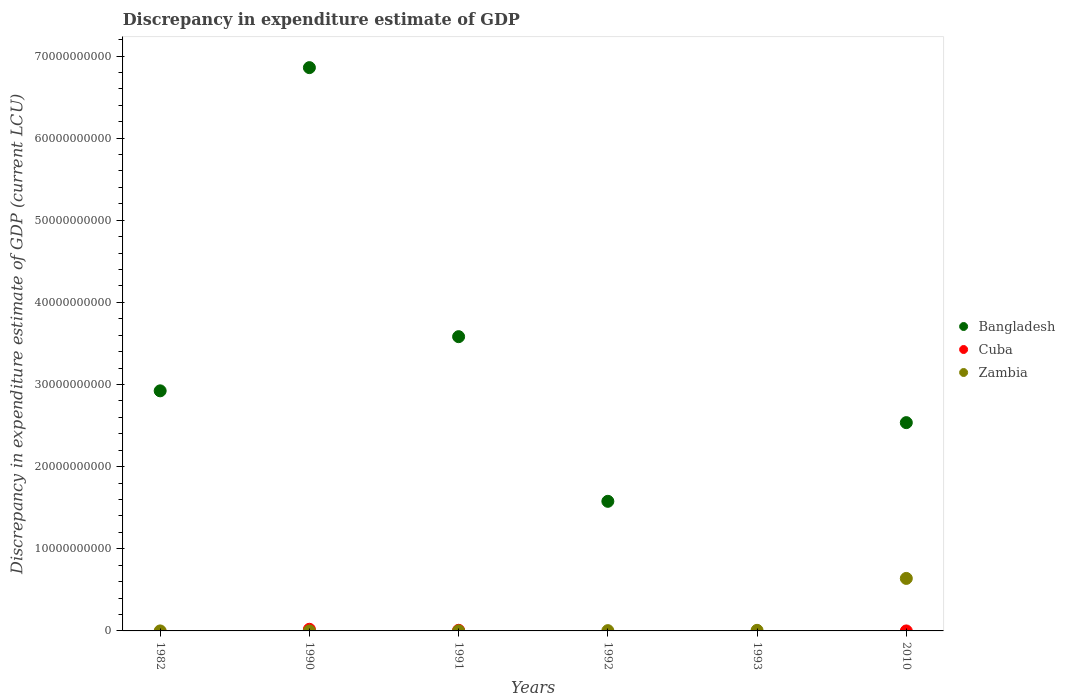What is the discrepancy in expenditure estimate of GDP in Bangladesh in 2010?
Provide a succinct answer. 2.54e+1. Across all years, what is the maximum discrepancy in expenditure estimate of GDP in Cuba?
Offer a terse response. 2.01e+08. Across all years, what is the minimum discrepancy in expenditure estimate of GDP in Cuba?
Provide a short and direct response. 0. In which year was the discrepancy in expenditure estimate of GDP in Bangladesh maximum?
Provide a short and direct response. 1990. What is the total discrepancy in expenditure estimate of GDP in Cuba in the graph?
Your answer should be very brief. 2.78e+08. What is the difference between the discrepancy in expenditure estimate of GDP in Bangladesh in 1992 and that in 2010?
Offer a very short reply. -9.58e+09. What is the difference between the discrepancy in expenditure estimate of GDP in Bangladesh in 1992 and the discrepancy in expenditure estimate of GDP in Cuba in 1990?
Offer a very short reply. 1.56e+1. What is the average discrepancy in expenditure estimate of GDP in Bangladesh per year?
Keep it short and to the point. 2.91e+1. In the year 1991, what is the difference between the discrepancy in expenditure estimate of GDP in Zambia and discrepancy in expenditure estimate of GDP in Cuba?
Make the answer very short. -6.36e+07. What is the ratio of the discrepancy in expenditure estimate of GDP in Bangladesh in 1990 to that in 1991?
Give a very brief answer. 1.91. What is the difference between the highest and the second highest discrepancy in expenditure estimate of GDP in Bangladesh?
Offer a very short reply. 3.28e+1. What is the difference between the highest and the lowest discrepancy in expenditure estimate of GDP in Zambia?
Provide a succinct answer. 6.39e+09. Is the sum of the discrepancy in expenditure estimate of GDP in Bangladesh in 1982 and 2010 greater than the maximum discrepancy in expenditure estimate of GDP in Cuba across all years?
Provide a succinct answer. Yes. Is it the case that in every year, the sum of the discrepancy in expenditure estimate of GDP in Zambia and discrepancy in expenditure estimate of GDP in Cuba  is greater than the discrepancy in expenditure estimate of GDP in Bangladesh?
Ensure brevity in your answer.  No. Does the discrepancy in expenditure estimate of GDP in Zambia monotonically increase over the years?
Provide a short and direct response. Yes. Is the discrepancy in expenditure estimate of GDP in Zambia strictly less than the discrepancy in expenditure estimate of GDP in Cuba over the years?
Give a very brief answer. No. How many dotlines are there?
Keep it short and to the point. 3. What is the difference between two consecutive major ticks on the Y-axis?
Offer a terse response. 1.00e+1. Are the values on the major ticks of Y-axis written in scientific E-notation?
Make the answer very short. No. Does the graph contain any zero values?
Ensure brevity in your answer.  Yes. Does the graph contain grids?
Ensure brevity in your answer.  No. How many legend labels are there?
Your answer should be very brief. 3. How are the legend labels stacked?
Your answer should be very brief. Vertical. What is the title of the graph?
Your response must be concise. Discrepancy in expenditure estimate of GDP. Does "Malawi" appear as one of the legend labels in the graph?
Provide a short and direct response. No. What is the label or title of the Y-axis?
Offer a very short reply. Discrepancy in expenditure estimate of GDP (current LCU). What is the Discrepancy in expenditure estimate of GDP (current LCU) in Bangladesh in 1982?
Provide a succinct answer. 2.92e+1. What is the Discrepancy in expenditure estimate of GDP (current LCU) of Zambia in 1982?
Offer a terse response. 800. What is the Discrepancy in expenditure estimate of GDP (current LCU) in Bangladesh in 1990?
Provide a short and direct response. 6.86e+1. What is the Discrepancy in expenditure estimate of GDP (current LCU) of Cuba in 1990?
Offer a very short reply. 2.01e+08. What is the Discrepancy in expenditure estimate of GDP (current LCU) in Zambia in 1990?
Ensure brevity in your answer.  1.37e+06. What is the Discrepancy in expenditure estimate of GDP (current LCU) in Bangladesh in 1991?
Make the answer very short. 3.58e+1. What is the Discrepancy in expenditure estimate of GDP (current LCU) of Cuba in 1991?
Provide a short and direct response. 7.71e+07. What is the Discrepancy in expenditure estimate of GDP (current LCU) in Zambia in 1991?
Keep it short and to the point. 1.34e+07. What is the Discrepancy in expenditure estimate of GDP (current LCU) of Bangladesh in 1992?
Make the answer very short. 1.58e+1. What is the Discrepancy in expenditure estimate of GDP (current LCU) in Zambia in 1992?
Offer a terse response. 3.46e+07. What is the Discrepancy in expenditure estimate of GDP (current LCU) in Cuba in 1993?
Make the answer very short. 0. What is the Discrepancy in expenditure estimate of GDP (current LCU) of Zambia in 1993?
Your response must be concise. 7.15e+07. What is the Discrepancy in expenditure estimate of GDP (current LCU) in Bangladesh in 2010?
Ensure brevity in your answer.  2.54e+1. What is the Discrepancy in expenditure estimate of GDP (current LCU) in Cuba in 2010?
Offer a terse response. 0. What is the Discrepancy in expenditure estimate of GDP (current LCU) in Zambia in 2010?
Give a very brief answer. 6.39e+09. Across all years, what is the maximum Discrepancy in expenditure estimate of GDP (current LCU) in Bangladesh?
Your answer should be very brief. 6.86e+1. Across all years, what is the maximum Discrepancy in expenditure estimate of GDP (current LCU) of Cuba?
Keep it short and to the point. 2.01e+08. Across all years, what is the maximum Discrepancy in expenditure estimate of GDP (current LCU) of Zambia?
Offer a very short reply. 6.39e+09. Across all years, what is the minimum Discrepancy in expenditure estimate of GDP (current LCU) in Cuba?
Keep it short and to the point. 0. Across all years, what is the minimum Discrepancy in expenditure estimate of GDP (current LCU) of Zambia?
Give a very brief answer. 800. What is the total Discrepancy in expenditure estimate of GDP (current LCU) in Bangladesh in the graph?
Provide a succinct answer. 1.75e+11. What is the total Discrepancy in expenditure estimate of GDP (current LCU) of Cuba in the graph?
Ensure brevity in your answer.  2.78e+08. What is the total Discrepancy in expenditure estimate of GDP (current LCU) of Zambia in the graph?
Your response must be concise. 6.51e+09. What is the difference between the Discrepancy in expenditure estimate of GDP (current LCU) of Bangladesh in 1982 and that in 1990?
Give a very brief answer. -3.94e+1. What is the difference between the Discrepancy in expenditure estimate of GDP (current LCU) in Zambia in 1982 and that in 1990?
Provide a short and direct response. -1.37e+06. What is the difference between the Discrepancy in expenditure estimate of GDP (current LCU) in Bangladesh in 1982 and that in 1991?
Give a very brief answer. -6.60e+09. What is the difference between the Discrepancy in expenditure estimate of GDP (current LCU) of Zambia in 1982 and that in 1991?
Provide a succinct answer. -1.34e+07. What is the difference between the Discrepancy in expenditure estimate of GDP (current LCU) in Bangladesh in 1982 and that in 1992?
Ensure brevity in your answer.  1.35e+1. What is the difference between the Discrepancy in expenditure estimate of GDP (current LCU) of Zambia in 1982 and that in 1992?
Offer a terse response. -3.46e+07. What is the difference between the Discrepancy in expenditure estimate of GDP (current LCU) of Zambia in 1982 and that in 1993?
Provide a succinct answer. -7.15e+07. What is the difference between the Discrepancy in expenditure estimate of GDP (current LCU) of Bangladesh in 1982 and that in 2010?
Offer a terse response. 3.87e+09. What is the difference between the Discrepancy in expenditure estimate of GDP (current LCU) in Zambia in 1982 and that in 2010?
Your answer should be very brief. -6.39e+09. What is the difference between the Discrepancy in expenditure estimate of GDP (current LCU) of Bangladesh in 1990 and that in 1991?
Your response must be concise. 3.28e+1. What is the difference between the Discrepancy in expenditure estimate of GDP (current LCU) of Cuba in 1990 and that in 1991?
Keep it short and to the point. 1.23e+08. What is the difference between the Discrepancy in expenditure estimate of GDP (current LCU) of Zambia in 1990 and that in 1991?
Provide a short and direct response. -1.21e+07. What is the difference between the Discrepancy in expenditure estimate of GDP (current LCU) of Bangladesh in 1990 and that in 1992?
Provide a succinct answer. 5.28e+1. What is the difference between the Discrepancy in expenditure estimate of GDP (current LCU) of Zambia in 1990 and that in 1992?
Ensure brevity in your answer.  -3.32e+07. What is the difference between the Discrepancy in expenditure estimate of GDP (current LCU) in Zambia in 1990 and that in 1993?
Ensure brevity in your answer.  -7.01e+07. What is the difference between the Discrepancy in expenditure estimate of GDP (current LCU) of Bangladesh in 1990 and that in 2010?
Your answer should be very brief. 4.32e+1. What is the difference between the Discrepancy in expenditure estimate of GDP (current LCU) in Zambia in 1990 and that in 2010?
Offer a terse response. -6.39e+09. What is the difference between the Discrepancy in expenditure estimate of GDP (current LCU) in Bangladesh in 1991 and that in 1992?
Ensure brevity in your answer.  2.00e+1. What is the difference between the Discrepancy in expenditure estimate of GDP (current LCU) of Zambia in 1991 and that in 1992?
Provide a succinct answer. -2.12e+07. What is the difference between the Discrepancy in expenditure estimate of GDP (current LCU) in Zambia in 1991 and that in 1993?
Provide a succinct answer. -5.81e+07. What is the difference between the Discrepancy in expenditure estimate of GDP (current LCU) of Bangladesh in 1991 and that in 2010?
Offer a very short reply. 1.05e+1. What is the difference between the Discrepancy in expenditure estimate of GDP (current LCU) in Zambia in 1991 and that in 2010?
Your response must be concise. -6.38e+09. What is the difference between the Discrepancy in expenditure estimate of GDP (current LCU) in Zambia in 1992 and that in 1993?
Make the answer very short. -3.69e+07. What is the difference between the Discrepancy in expenditure estimate of GDP (current LCU) in Bangladesh in 1992 and that in 2010?
Offer a very short reply. -9.58e+09. What is the difference between the Discrepancy in expenditure estimate of GDP (current LCU) of Zambia in 1992 and that in 2010?
Your answer should be compact. -6.36e+09. What is the difference between the Discrepancy in expenditure estimate of GDP (current LCU) in Zambia in 1993 and that in 2010?
Give a very brief answer. -6.32e+09. What is the difference between the Discrepancy in expenditure estimate of GDP (current LCU) of Bangladesh in 1982 and the Discrepancy in expenditure estimate of GDP (current LCU) of Cuba in 1990?
Your answer should be compact. 2.90e+1. What is the difference between the Discrepancy in expenditure estimate of GDP (current LCU) of Bangladesh in 1982 and the Discrepancy in expenditure estimate of GDP (current LCU) of Zambia in 1990?
Make the answer very short. 2.92e+1. What is the difference between the Discrepancy in expenditure estimate of GDP (current LCU) of Bangladesh in 1982 and the Discrepancy in expenditure estimate of GDP (current LCU) of Cuba in 1991?
Keep it short and to the point. 2.92e+1. What is the difference between the Discrepancy in expenditure estimate of GDP (current LCU) of Bangladesh in 1982 and the Discrepancy in expenditure estimate of GDP (current LCU) of Zambia in 1991?
Your answer should be compact. 2.92e+1. What is the difference between the Discrepancy in expenditure estimate of GDP (current LCU) in Bangladesh in 1982 and the Discrepancy in expenditure estimate of GDP (current LCU) in Zambia in 1992?
Keep it short and to the point. 2.92e+1. What is the difference between the Discrepancy in expenditure estimate of GDP (current LCU) in Bangladesh in 1982 and the Discrepancy in expenditure estimate of GDP (current LCU) in Zambia in 1993?
Offer a terse response. 2.92e+1. What is the difference between the Discrepancy in expenditure estimate of GDP (current LCU) of Bangladesh in 1982 and the Discrepancy in expenditure estimate of GDP (current LCU) of Zambia in 2010?
Offer a very short reply. 2.28e+1. What is the difference between the Discrepancy in expenditure estimate of GDP (current LCU) of Bangladesh in 1990 and the Discrepancy in expenditure estimate of GDP (current LCU) of Cuba in 1991?
Your response must be concise. 6.85e+1. What is the difference between the Discrepancy in expenditure estimate of GDP (current LCU) in Bangladesh in 1990 and the Discrepancy in expenditure estimate of GDP (current LCU) in Zambia in 1991?
Give a very brief answer. 6.86e+1. What is the difference between the Discrepancy in expenditure estimate of GDP (current LCU) of Cuba in 1990 and the Discrepancy in expenditure estimate of GDP (current LCU) of Zambia in 1991?
Make the answer very short. 1.87e+08. What is the difference between the Discrepancy in expenditure estimate of GDP (current LCU) of Bangladesh in 1990 and the Discrepancy in expenditure estimate of GDP (current LCU) of Zambia in 1992?
Make the answer very short. 6.86e+1. What is the difference between the Discrepancy in expenditure estimate of GDP (current LCU) of Cuba in 1990 and the Discrepancy in expenditure estimate of GDP (current LCU) of Zambia in 1992?
Your answer should be very brief. 1.66e+08. What is the difference between the Discrepancy in expenditure estimate of GDP (current LCU) of Bangladesh in 1990 and the Discrepancy in expenditure estimate of GDP (current LCU) of Zambia in 1993?
Keep it short and to the point. 6.85e+1. What is the difference between the Discrepancy in expenditure estimate of GDP (current LCU) of Cuba in 1990 and the Discrepancy in expenditure estimate of GDP (current LCU) of Zambia in 1993?
Your answer should be very brief. 1.29e+08. What is the difference between the Discrepancy in expenditure estimate of GDP (current LCU) in Bangladesh in 1990 and the Discrepancy in expenditure estimate of GDP (current LCU) in Zambia in 2010?
Offer a very short reply. 6.22e+1. What is the difference between the Discrepancy in expenditure estimate of GDP (current LCU) of Cuba in 1990 and the Discrepancy in expenditure estimate of GDP (current LCU) of Zambia in 2010?
Your answer should be compact. -6.19e+09. What is the difference between the Discrepancy in expenditure estimate of GDP (current LCU) of Bangladesh in 1991 and the Discrepancy in expenditure estimate of GDP (current LCU) of Zambia in 1992?
Your response must be concise. 3.58e+1. What is the difference between the Discrepancy in expenditure estimate of GDP (current LCU) of Cuba in 1991 and the Discrepancy in expenditure estimate of GDP (current LCU) of Zambia in 1992?
Provide a short and direct response. 4.25e+07. What is the difference between the Discrepancy in expenditure estimate of GDP (current LCU) of Bangladesh in 1991 and the Discrepancy in expenditure estimate of GDP (current LCU) of Zambia in 1993?
Give a very brief answer. 3.58e+1. What is the difference between the Discrepancy in expenditure estimate of GDP (current LCU) of Cuba in 1991 and the Discrepancy in expenditure estimate of GDP (current LCU) of Zambia in 1993?
Provide a succinct answer. 5.58e+06. What is the difference between the Discrepancy in expenditure estimate of GDP (current LCU) in Bangladesh in 1991 and the Discrepancy in expenditure estimate of GDP (current LCU) in Zambia in 2010?
Ensure brevity in your answer.  2.94e+1. What is the difference between the Discrepancy in expenditure estimate of GDP (current LCU) in Cuba in 1991 and the Discrepancy in expenditure estimate of GDP (current LCU) in Zambia in 2010?
Offer a terse response. -6.32e+09. What is the difference between the Discrepancy in expenditure estimate of GDP (current LCU) of Bangladesh in 1992 and the Discrepancy in expenditure estimate of GDP (current LCU) of Zambia in 1993?
Keep it short and to the point. 1.57e+1. What is the difference between the Discrepancy in expenditure estimate of GDP (current LCU) of Bangladesh in 1992 and the Discrepancy in expenditure estimate of GDP (current LCU) of Zambia in 2010?
Provide a short and direct response. 9.39e+09. What is the average Discrepancy in expenditure estimate of GDP (current LCU) of Bangladesh per year?
Your answer should be very brief. 2.91e+1. What is the average Discrepancy in expenditure estimate of GDP (current LCU) in Cuba per year?
Keep it short and to the point. 4.63e+07. What is the average Discrepancy in expenditure estimate of GDP (current LCU) in Zambia per year?
Keep it short and to the point. 1.09e+09. In the year 1982, what is the difference between the Discrepancy in expenditure estimate of GDP (current LCU) of Bangladesh and Discrepancy in expenditure estimate of GDP (current LCU) of Zambia?
Give a very brief answer. 2.92e+1. In the year 1990, what is the difference between the Discrepancy in expenditure estimate of GDP (current LCU) in Bangladesh and Discrepancy in expenditure estimate of GDP (current LCU) in Cuba?
Your answer should be compact. 6.84e+1. In the year 1990, what is the difference between the Discrepancy in expenditure estimate of GDP (current LCU) of Bangladesh and Discrepancy in expenditure estimate of GDP (current LCU) of Zambia?
Keep it short and to the point. 6.86e+1. In the year 1990, what is the difference between the Discrepancy in expenditure estimate of GDP (current LCU) in Cuba and Discrepancy in expenditure estimate of GDP (current LCU) in Zambia?
Provide a short and direct response. 1.99e+08. In the year 1991, what is the difference between the Discrepancy in expenditure estimate of GDP (current LCU) of Bangladesh and Discrepancy in expenditure estimate of GDP (current LCU) of Cuba?
Your answer should be very brief. 3.58e+1. In the year 1991, what is the difference between the Discrepancy in expenditure estimate of GDP (current LCU) in Bangladesh and Discrepancy in expenditure estimate of GDP (current LCU) in Zambia?
Provide a succinct answer. 3.58e+1. In the year 1991, what is the difference between the Discrepancy in expenditure estimate of GDP (current LCU) of Cuba and Discrepancy in expenditure estimate of GDP (current LCU) of Zambia?
Provide a short and direct response. 6.36e+07. In the year 1992, what is the difference between the Discrepancy in expenditure estimate of GDP (current LCU) of Bangladesh and Discrepancy in expenditure estimate of GDP (current LCU) of Zambia?
Provide a short and direct response. 1.57e+1. In the year 2010, what is the difference between the Discrepancy in expenditure estimate of GDP (current LCU) of Bangladesh and Discrepancy in expenditure estimate of GDP (current LCU) of Zambia?
Provide a succinct answer. 1.90e+1. What is the ratio of the Discrepancy in expenditure estimate of GDP (current LCU) of Bangladesh in 1982 to that in 1990?
Provide a short and direct response. 0.43. What is the ratio of the Discrepancy in expenditure estimate of GDP (current LCU) in Zambia in 1982 to that in 1990?
Offer a terse response. 0. What is the ratio of the Discrepancy in expenditure estimate of GDP (current LCU) in Bangladesh in 1982 to that in 1991?
Provide a short and direct response. 0.82. What is the ratio of the Discrepancy in expenditure estimate of GDP (current LCU) of Zambia in 1982 to that in 1991?
Offer a terse response. 0. What is the ratio of the Discrepancy in expenditure estimate of GDP (current LCU) of Bangladesh in 1982 to that in 1992?
Ensure brevity in your answer.  1.85. What is the ratio of the Discrepancy in expenditure estimate of GDP (current LCU) of Bangladesh in 1982 to that in 2010?
Your response must be concise. 1.15. What is the ratio of the Discrepancy in expenditure estimate of GDP (current LCU) of Zambia in 1982 to that in 2010?
Offer a very short reply. 0. What is the ratio of the Discrepancy in expenditure estimate of GDP (current LCU) of Bangladesh in 1990 to that in 1991?
Give a very brief answer. 1.91. What is the ratio of the Discrepancy in expenditure estimate of GDP (current LCU) of Cuba in 1990 to that in 1991?
Keep it short and to the point. 2.6. What is the ratio of the Discrepancy in expenditure estimate of GDP (current LCU) in Zambia in 1990 to that in 1991?
Keep it short and to the point. 0.1. What is the ratio of the Discrepancy in expenditure estimate of GDP (current LCU) of Bangladesh in 1990 to that in 1992?
Offer a terse response. 4.35. What is the ratio of the Discrepancy in expenditure estimate of GDP (current LCU) of Zambia in 1990 to that in 1992?
Provide a short and direct response. 0.04. What is the ratio of the Discrepancy in expenditure estimate of GDP (current LCU) in Zambia in 1990 to that in 1993?
Offer a very short reply. 0.02. What is the ratio of the Discrepancy in expenditure estimate of GDP (current LCU) of Bangladesh in 1990 to that in 2010?
Your answer should be very brief. 2.7. What is the ratio of the Discrepancy in expenditure estimate of GDP (current LCU) of Bangladesh in 1991 to that in 1992?
Make the answer very short. 2.27. What is the ratio of the Discrepancy in expenditure estimate of GDP (current LCU) of Zambia in 1991 to that in 1992?
Give a very brief answer. 0.39. What is the ratio of the Discrepancy in expenditure estimate of GDP (current LCU) of Zambia in 1991 to that in 1993?
Ensure brevity in your answer.  0.19. What is the ratio of the Discrepancy in expenditure estimate of GDP (current LCU) of Bangladesh in 1991 to that in 2010?
Keep it short and to the point. 1.41. What is the ratio of the Discrepancy in expenditure estimate of GDP (current LCU) of Zambia in 1991 to that in 2010?
Your response must be concise. 0. What is the ratio of the Discrepancy in expenditure estimate of GDP (current LCU) in Zambia in 1992 to that in 1993?
Give a very brief answer. 0.48. What is the ratio of the Discrepancy in expenditure estimate of GDP (current LCU) in Bangladesh in 1992 to that in 2010?
Ensure brevity in your answer.  0.62. What is the ratio of the Discrepancy in expenditure estimate of GDP (current LCU) of Zambia in 1992 to that in 2010?
Your response must be concise. 0.01. What is the ratio of the Discrepancy in expenditure estimate of GDP (current LCU) of Zambia in 1993 to that in 2010?
Provide a short and direct response. 0.01. What is the difference between the highest and the second highest Discrepancy in expenditure estimate of GDP (current LCU) of Bangladesh?
Make the answer very short. 3.28e+1. What is the difference between the highest and the second highest Discrepancy in expenditure estimate of GDP (current LCU) in Zambia?
Provide a short and direct response. 6.32e+09. What is the difference between the highest and the lowest Discrepancy in expenditure estimate of GDP (current LCU) of Bangladesh?
Your answer should be very brief. 6.86e+1. What is the difference between the highest and the lowest Discrepancy in expenditure estimate of GDP (current LCU) in Cuba?
Offer a very short reply. 2.01e+08. What is the difference between the highest and the lowest Discrepancy in expenditure estimate of GDP (current LCU) of Zambia?
Give a very brief answer. 6.39e+09. 